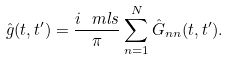<formula> <loc_0><loc_0><loc_500><loc_500>\hat { g } ( t , t ^ { \prime } ) = \frac { i \ m l s } \pi \sum _ { n = 1 } ^ { N } \hat { G } _ { n n } ( t , t ^ { \prime } ) .</formula> 